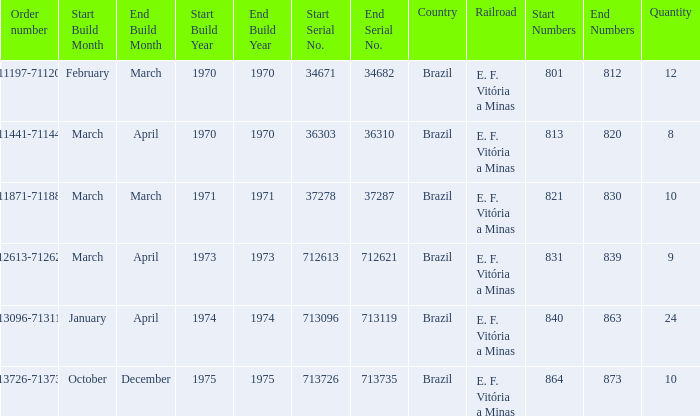The order number 713726-713735 has what serial number? 713726-713735. 